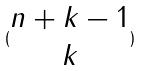<formula> <loc_0><loc_0><loc_500><loc_500>( \begin{matrix} n + k - 1 \\ k \end{matrix} )</formula> 